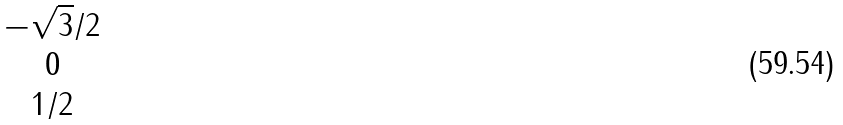Convert formula to latex. <formula><loc_0><loc_0><loc_500><loc_500>\begin{matrix} - \sqrt { 3 } / 2 \\ 0 \\ 1 / 2 \end{matrix}</formula> 